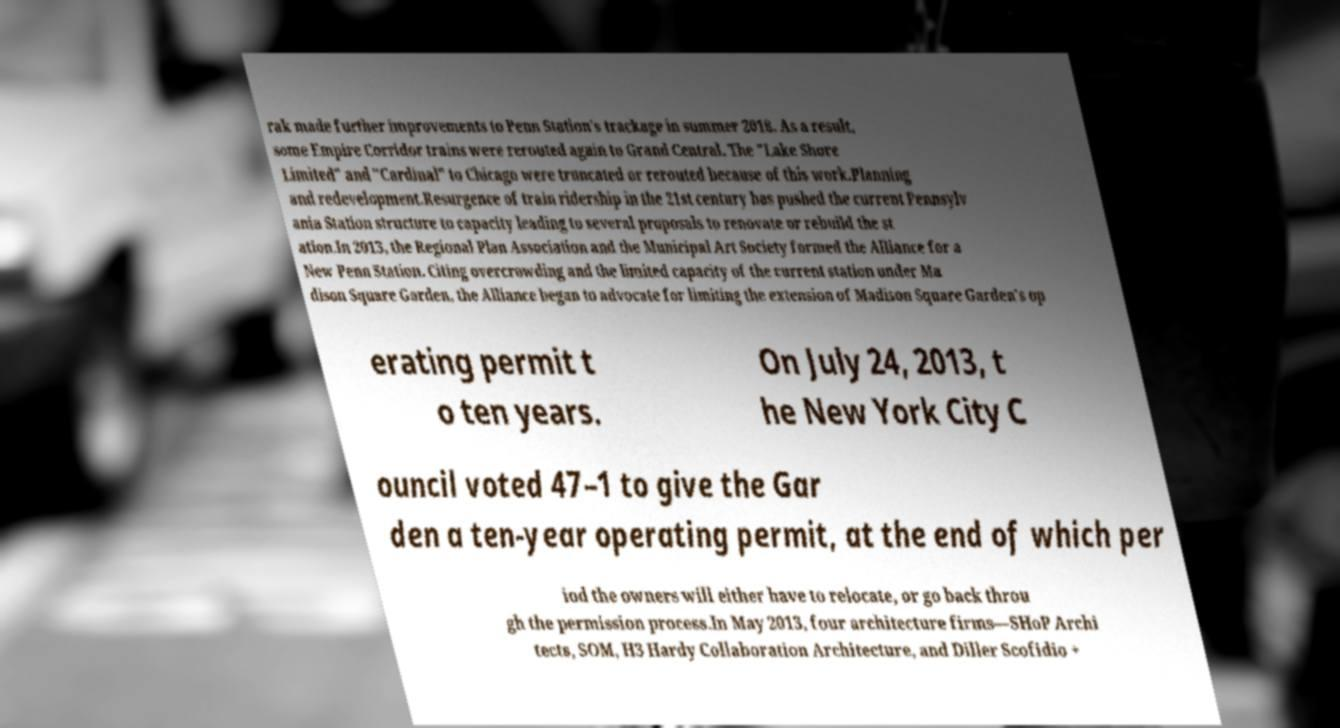Can you read and provide the text displayed in the image?This photo seems to have some interesting text. Can you extract and type it out for me? rak made further improvements to Penn Station's trackage in summer 2018. As a result, some Empire Corridor trains were rerouted again to Grand Central. The "Lake Shore Limited" and "Cardinal" to Chicago were truncated or rerouted because of this work.Planning and redevelopment.Resurgence of train ridership in the 21st century has pushed the current Pennsylv ania Station structure to capacity leading to several proposals to renovate or rebuild the st ation.In 2013, the Regional Plan Association and the Municipal Art Society formed the Alliance for a New Penn Station. Citing overcrowding and the limited capacity of the current station under Ma dison Square Garden, the Alliance began to advocate for limiting the extension of Madison Square Garden's op erating permit t o ten years. On July 24, 2013, t he New York City C ouncil voted 47–1 to give the Gar den a ten-year operating permit, at the end of which per iod the owners will either have to relocate, or go back throu gh the permission process.In May 2013, four architecture firms—SHoP Archi tects, SOM, H3 Hardy Collaboration Architecture, and Diller Scofidio + 